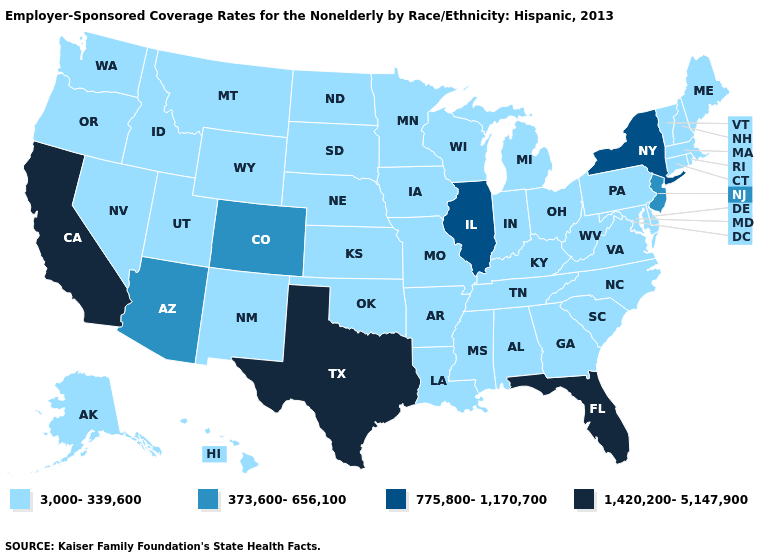What is the value of South Carolina?
Answer briefly. 3,000-339,600. Which states have the lowest value in the USA?
Keep it brief. Alabama, Alaska, Arkansas, Connecticut, Delaware, Georgia, Hawaii, Idaho, Indiana, Iowa, Kansas, Kentucky, Louisiana, Maine, Maryland, Massachusetts, Michigan, Minnesota, Mississippi, Missouri, Montana, Nebraska, Nevada, New Hampshire, New Mexico, North Carolina, North Dakota, Ohio, Oklahoma, Oregon, Pennsylvania, Rhode Island, South Carolina, South Dakota, Tennessee, Utah, Vermont, Virginia, Washington, West Virginia, Wisconsin, Wyoming. What is the value of Wyoming?
Be succinct. 3,000-339,600. What is the lowest value in the USA?
Keep it brief. 3,000-339,600. What is the value of Louisiana?
Concise answer only. 3,000-339,600. Name the states that have a value in the range 1,420,200-5,147,900?
Answer briefly. California, Florida, Texas. Does Rhode Island have the lowest value in the USA?
Be succinct. Yes. What is the lowest value in the South?
Keep it brief. 3,000-339,600. Name the states that have a value in the range 373,600-656,100?
Quick response, please. Arizona, Colorado, New Jersey. Name the states that have a value in the range 3,000-339,600?
Give a very brief answer. Alabama, Alaska, Arkansas, Connecticut, Delaware, Georgia, Hawaii, Idaho, Indiana, Iowa, Kansas, Kentucky, Louisiana, Maine, Maryland, Massachusetts, Michigan, Minnesota, Mississippi, Missouri, Montana, Nebraska, Nevada, New Hampshire, New Mexico, North Carolina, North Dakota, Ohio, Oklahoma, Oregon, Pennsylvania, Rhode Island, South Carolina, South Dakota, Tennessee, Utah, Vermont, Virginia, Washington, West Virginia, Wisconsin, Wyoming. What is the highest value in the USA?
Quick response, please. 1,420,200-5,147,900. Does the map have missing data?
Write a very short answer. No. Is the legend a continuous bar?
Keep it brief. No. Does Texas have the highest value in the USA?
Answer briefly. Yes. What is the lowest value in the USA?
Write a very short answer. 3,000-339,600. 